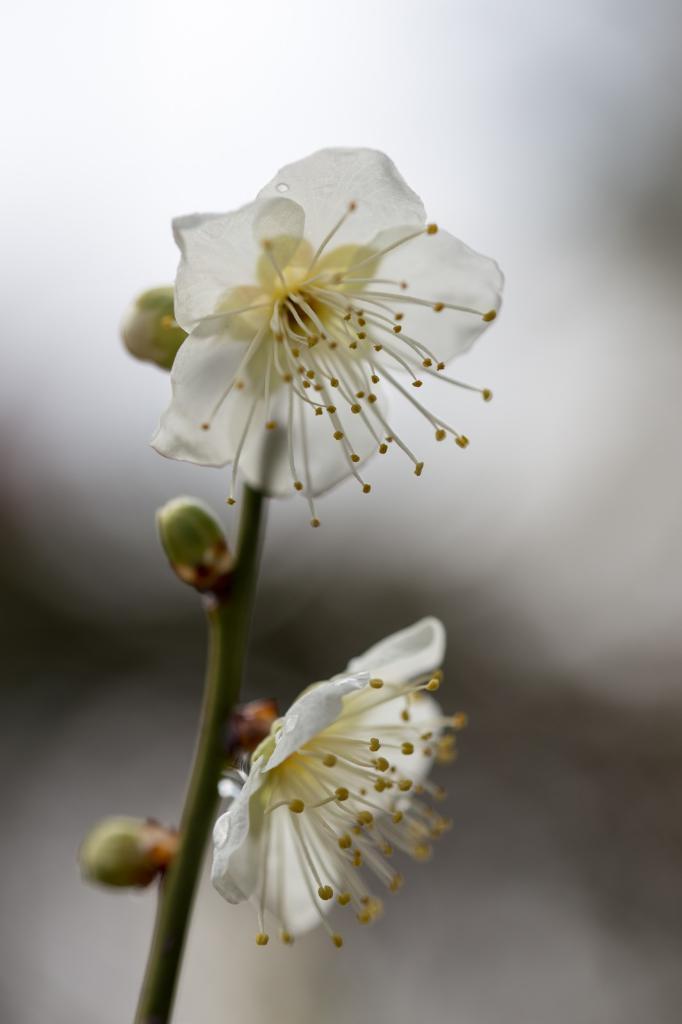Describe this image in one or two sentences. In this picture I can see there are two white flowers attached to the stem and there are few buds and the backdrop is blurred. 